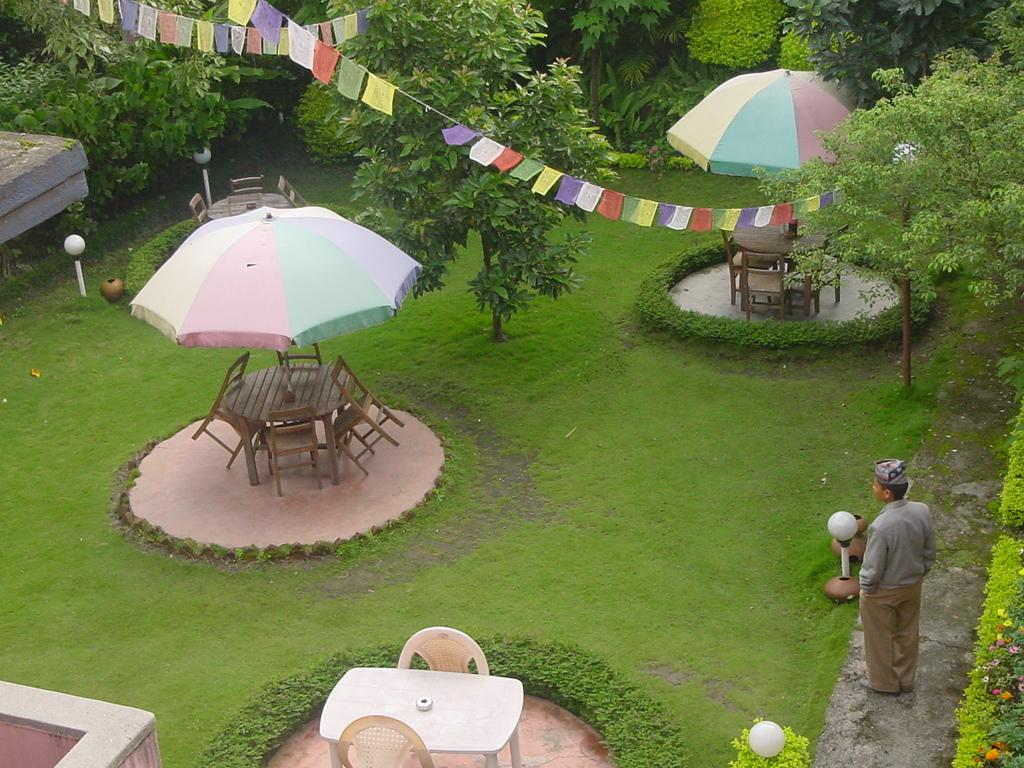What is the person in the image doing? The person in the image is standing on the way. What type of furniture can be seen in the image? There are wooden tables and wooden chairs in the image. What type of shelter from the sun or rain is present in the image? There are umbrellas in the image. What type of vegetation is present in the image? There is grass and trees in the image. What type of structures are present in the image? There are light poles and a wall in the image. What additional decorative elements are present in the image? There are flag ribbons in the image. What type of brick is used to build the stream in the image? There is no stream present in the image, and therefore no bricks are used to build it. 